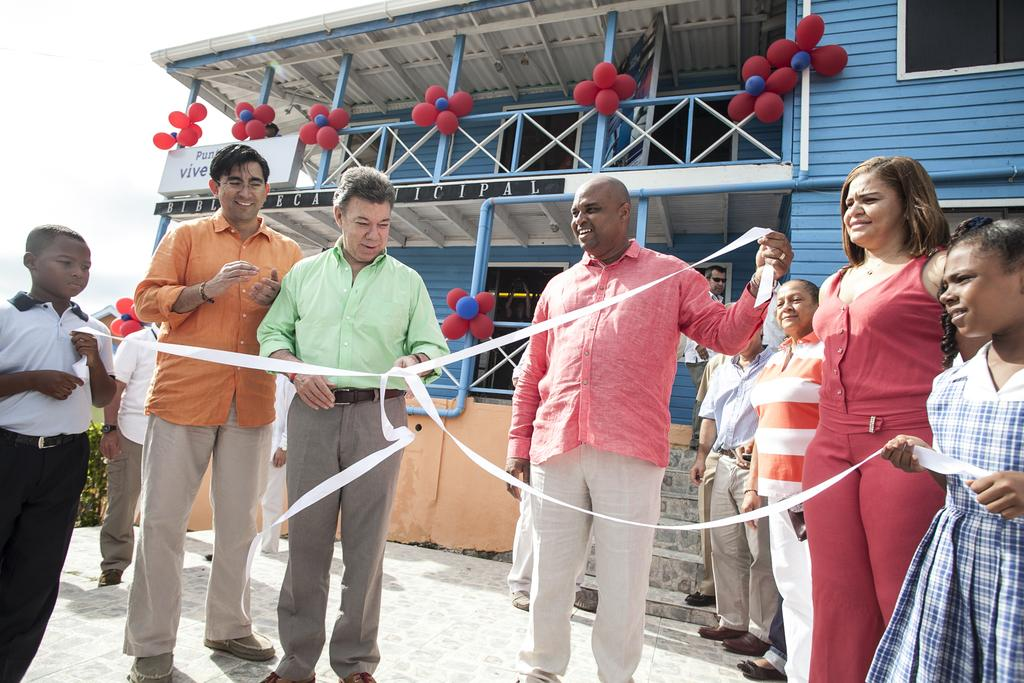How many people are in the group in the image? There is a group of people in the image, but the exact number is not specified. What are some people in the group holding? Some people in the group are holding a white object. What can be seen in the background of the image? There is a blue building in the background of the image. What type of connection is being made between the people and the white object in the image? There is no indication of a connection being made between the people and the white object in the image. 